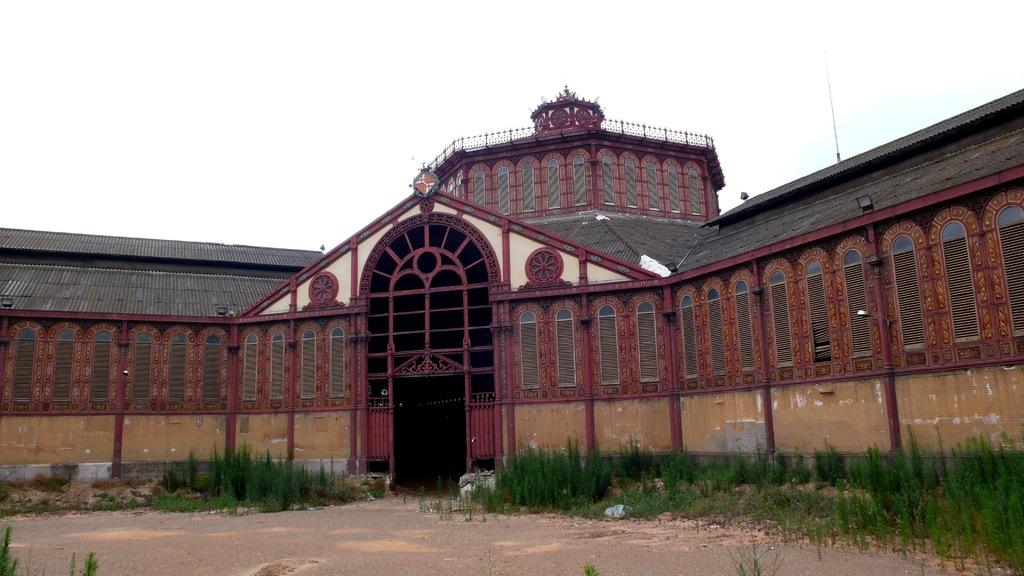What type of structure is in the image? There is a building in the image. What feature is in the center of the building? The building has a door in the center. What other openings can be seen on the building? The building has windows. What is located in front of the building? There are plants and stones in front of the building. What is visible at the top of the image? The sky is visible at the top of the image. What type of fire can be seen burning in front of the building? There is no fire present in the image; it features a building with plants and stones in front of it. What property is being sold or rented in the image? There is no indication of a property being sold or rented in the image; it simply shows a building with plants and stones in front of it. 